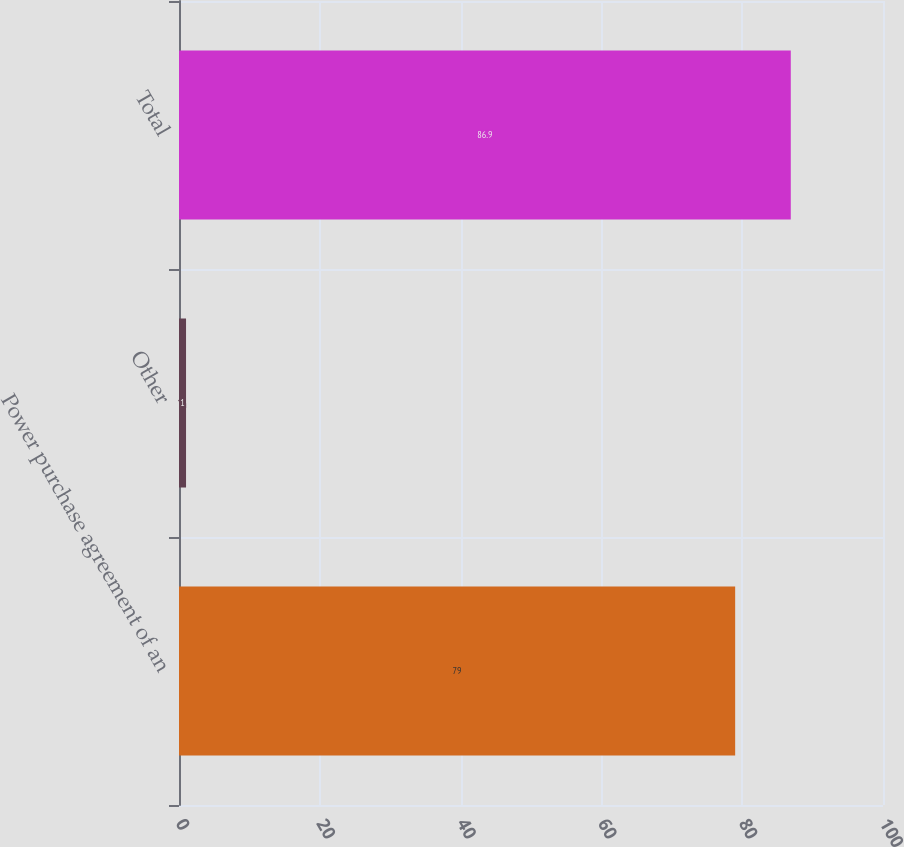Convert chart. <chart><loc_0><loc_0><loc_500><loc_500><bar_chart><fcel>Power purchase agreement of an<fcel>Other<fcel>Total<nl><fcel>79<fcel>1<fcel>86.9<nl></chart> 